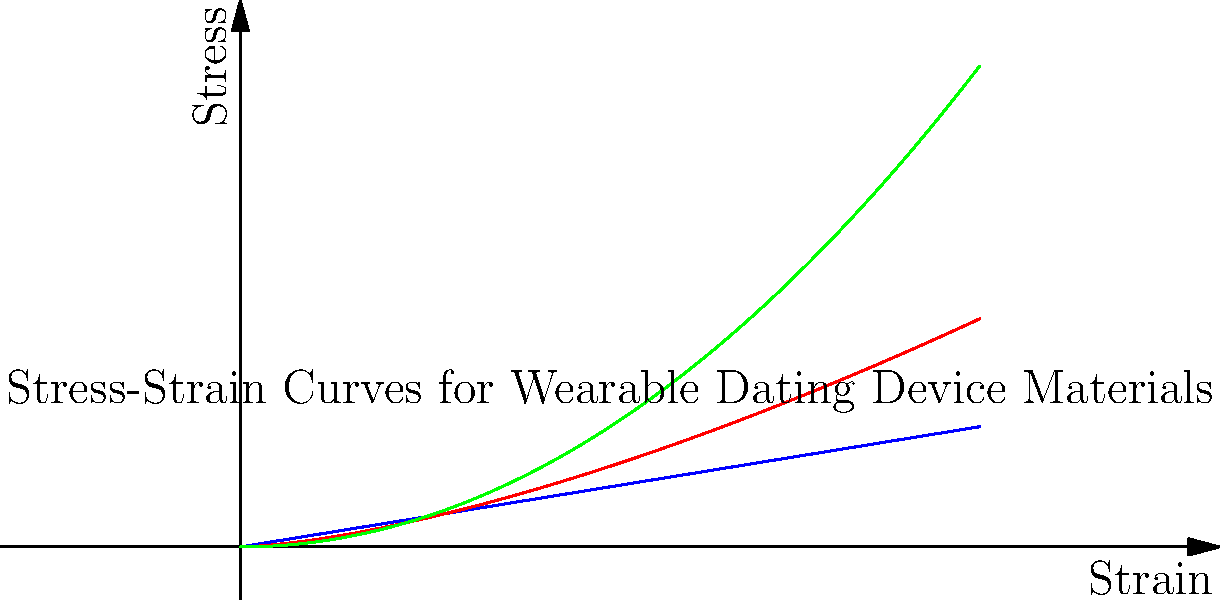Based on the stress-strain curves shown for three different materials used in wearable dating devices, which material would be most suitable for a flexible, skin-adherent sensor that needs to withstand repeated stretching and bending? To determine the most suitable material for a flexible, skin-adherent sensor in a wearable dating device, we need to analyze the stress-strain curves for each material:

1. Material A (blue line): Shows a linear relationship between stress and strain, indicating elastic behavior. This suggests it's a rigid material that doesn't easily deform.

2. Material B (red line): Exhibits a non-linear relationship with a gradual increase in slope. This indicates some initial flexibility followed by stiffening under higher strain.

3. Material C (green line): Demonstrates a non-linear relationship with a more gradual increase in stress as strain increases. This suggests the material is initially very flexible and becomes stiffer at higher strains, but less dramatically than Material B.

For a flexible, skin-adherent sensor that needs to withstand repeated stretching and bending:

- We need a material that can deform easily at low strains (initial flexibility).
- The material should also have some resistance to deformation at higher strains to maintain structural integrity.
- A gradual transition from low to high stiffness is preferable to avoid sudden failure.

Material C best meets these criteria. It offers:
1. High flexibility at low strains (initial part of the curve is flatter).
2. Gradual increase in stiffness at higher strains (curve becomes steeper but not abruptly).
3. Better ability to distribute stress over a range of strains, reducing the risk of sudden failure.

This behavior is ideal for a sensor that needs to conform to skin movements while maintaining its functionality and structural integrity.
Answer: Material C 